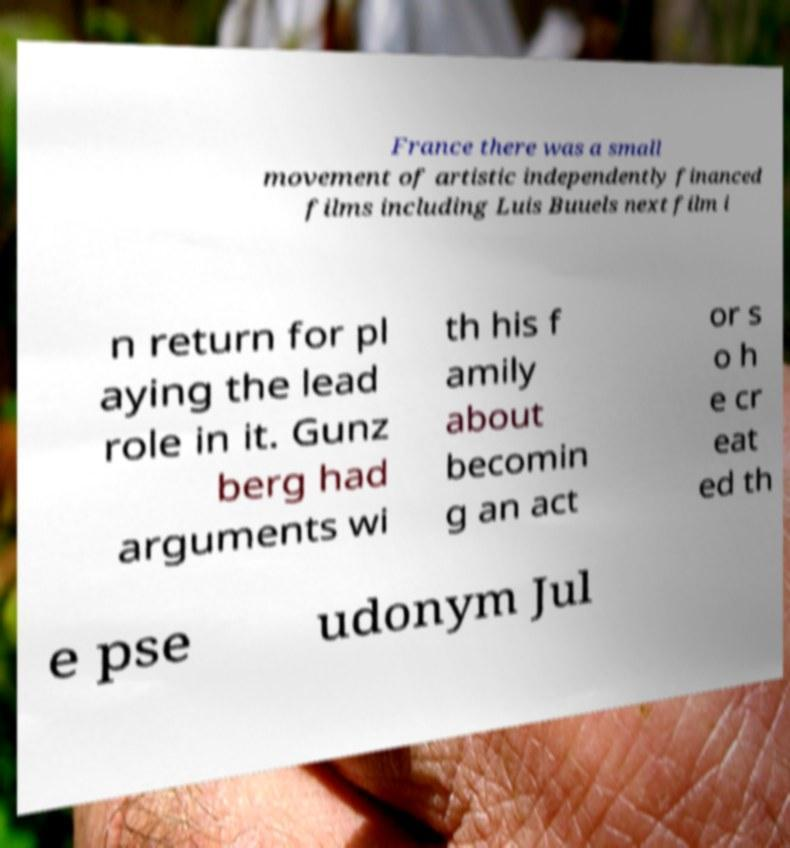There's text embedded in this image that I need extracted. Can you transcribe it verbatim? France there was a small movement of artistic independently financed films including Luis Buuels next film i n return for pl aying the lead role in it. Gunz berg had arguments wi th his f amily about becomin g an act or s o h e cr eat ed th e pse udonym Jul 